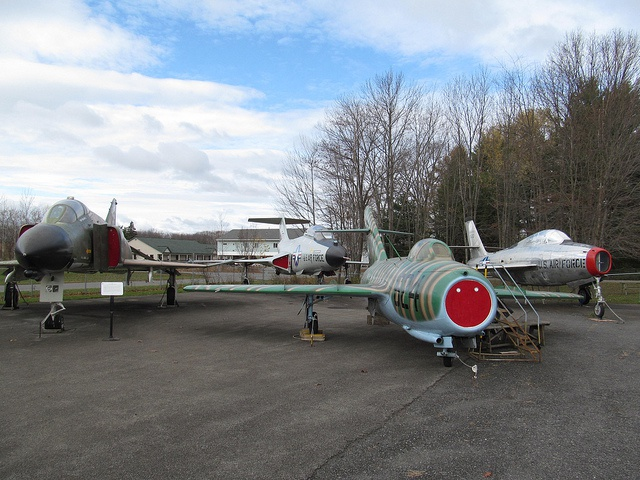Describe the objects in this image and their specific colors. I can see airplane in lightgray, darkgray, gray, and brown tones, airplane in lightgray, black, gray, darkgray, and maroon tones, airplane in lightgray, black, gray, and darkgray tones, and airplane in lightgray, gray, black, and darkgray tones in this image. 